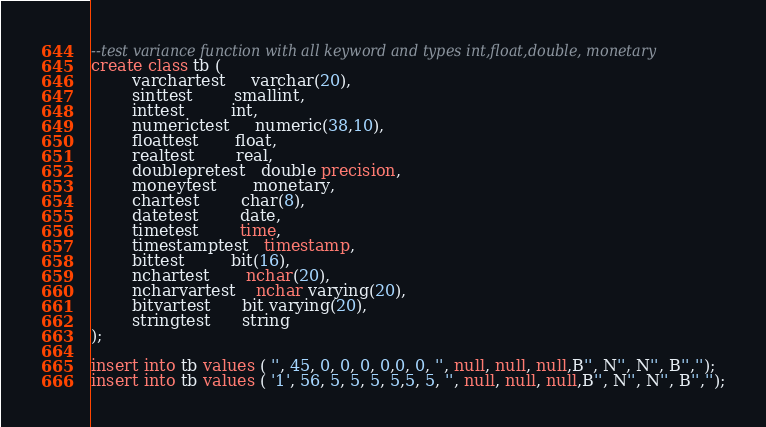<code> <loc_0><loc_0><loc_500><loc_500><_SQL_>--test variance function with all keyword and types int,float,double, monetary 
create class tb (
		varchartest     varchar(20),
		sinttest        smallint,
		inttest         int,
		numerictest     numeric(38,10),
		floattest       float,
		realtest        real,
		doublepretest   double precision,
		moneytest       monetary,
		chartest        char(8),
		datetest        date,
		timetest        time,
		timestamptest   timestamp,
		bittest         bit(16),
		nchartest       nchar(20),
		ncharvartest    nchar varying(20),
		bitvartest      bit varying(20),
		stringtest      string
);

insert into tb values ( '', 45, 0, 0, 0, 0,0, 0, '', null, null, null,B'', N'', N'', B'','');
insert into tb values ( '1', 56, 5, 5, 5, 5,5, 5, '', null, null, null,B'', N'', N'', B'','');</code> 